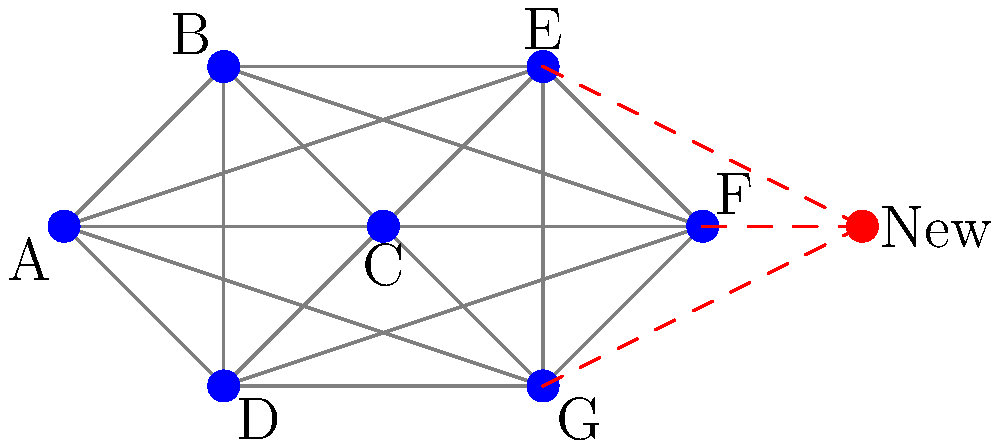In the mesh network topology shown above, a new node (in red) needs to be added to accommodate increasing users and devices. What is the minimum number of connections required to integrate this new node while maintaining optimal network performance and redundancy? To determine the minimum number of connections required for the new node, we need to consider the following factors:

1. Connectivity: The new node should be connected to the existing network.
2. Redundancy: Multiple connections provide fault tolerance and improve network reliability.
3. Performance: Sufficient connections ensure efficient data routing and load balancing.
4. Scalability: The solution should allow for future growth without compromising the network's integrity.

Step-by-step analysis:

1. Observe the existing network structure:
   - The current mesh topology has 7 nodes (A to G) with full connectivity.
   - Each node is connected to every other node, providing maximum redundancy.

2. Consider the new node's position:
   - The new node is positioned near nodes E, F, and G.

3. Determine the minimum connections:
   - To ensure basic connectivity, the new node needs at least one connection.
   - For redundancy, a minimum of two connections is recommended.
   - To maintain optimal performance and load balancing, connecting to three nearby nodes is ideal.

4. Analyze the impact of connections:
   - One connection: Provides basic connectivity but creates a single point of failure.
   - Two connections: Offers some redundancy but may not be optimal for load balancing.
   - Three connections: Provides good redundancy, load balancing, and maintains the mesh structure.

5. Consider scalability:
   - Three connections allow for future growth without immediate restructuring.
   - It maintains the mesh topology's characteristics while avoiding excessive connections.

6. Evaluate the trade-off:
   - While more connections (e.g., connecting to all existing nodes) would provide maximum redundancy, it would also increase complexity and resource usage.
   - Three connections strike a balance between performance, redundancy, and scalability.

Therefore, the minimum number of connections required to integrate the new node while maintaining optimal network performance and redundancy is 3, as shown by the red dashed lines in the diagram.
Answer: 3 connections 